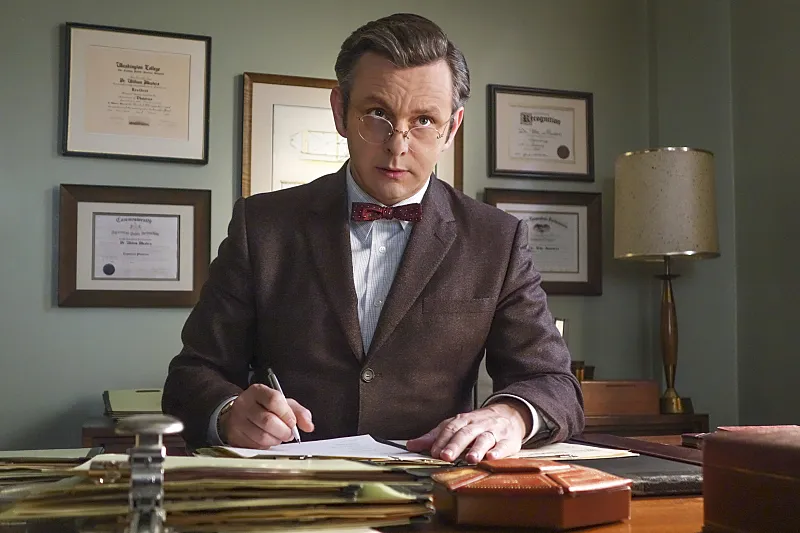What is this photo about? This photo captures a character from a popular television series, portrayed by an acclaimed actor. The character, a serious and dedicated medical professional, is shown dressed in a brown suit with a striking red bowtie, embodying his role with a focused expression as he pens down notes. His office, cluttered with papers and enriched with numerous academic certificates on the wall, paints him as a deeply engaged and authoritative figure in his field. This scene effectively conveys the character's intensity and professionalism, inviting viewers into the nuanced world of his professional and personal challenges. 